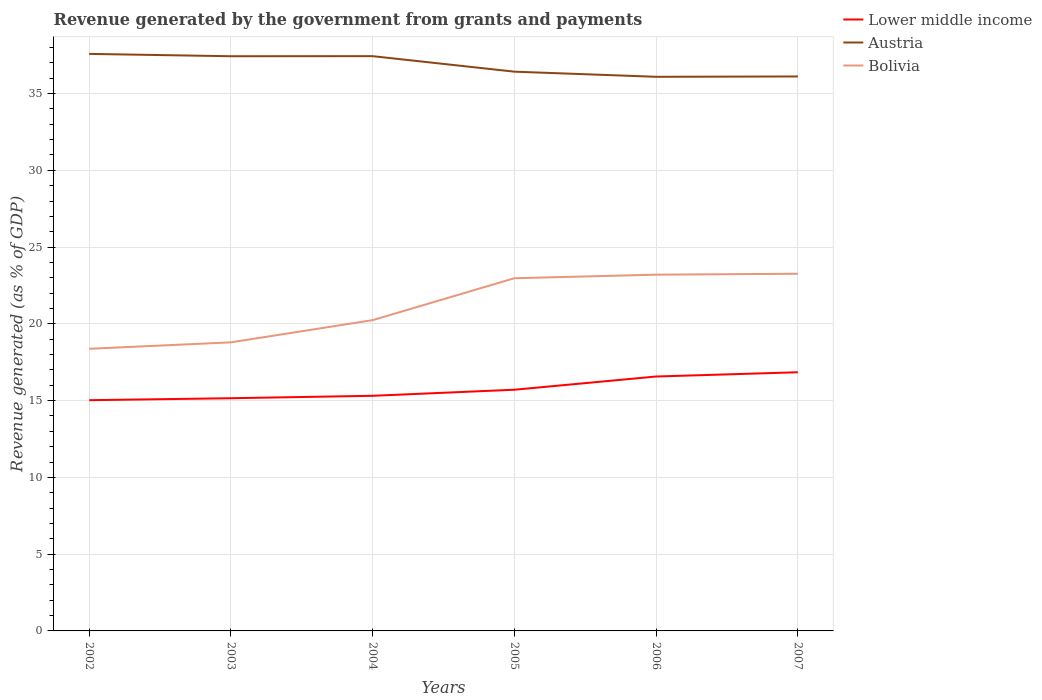Is the number of lines equal to the number of legend labels?
Make the answer very short. Yes. Across all years, what is the maximum revenue generated by the government in Lower middle income?
Offer a terse response. 15.03. What is the total revenue generated by the government in Austria in the graph?
Ensure brevity in your answer.  1.32. What is the difference between the highest and the second highest revenue generated by the government in Lower middle income?
Offer a terse response. 1.82. How many years are there in the graph?
Keep it short and to the point. 6. What is the difference between two consecutive major ticks on the Y-axis?
Provide a short and direct response. 5. Are the values on the major ticks of Y-axis written in scientific E-notation?
Ensure brevity in your answer.  No. Does the graph contain any zero values?
Make the answer very short. No. Where does the legend appear in the graph?
Your answer should be compact. Top right. How are the legend labels stacked?
Provide a succinct answer. Vertical. What is the title of the graph?
Offer a terse response. Revenue generated by the government from grants and payments. Does "Costa Rica" appear as one of the legend labels in the graph?
Offer a terse response. No. What is the label or title of the X-axis?
Your answer should be very brief. Years. What is the label or title of the Y-axis?
Keep it short and to the point. Revenue generated (as % of GDP). What is the Revenue generated (as % of GDP) of Lower middle income in 2002?
Provide a short and direct response. 15.03. What is the Revenue generated (as % of GDP) of Austria in 2002?
Offer a terse response. 37.58. What is the Revenue generated (as % of GDP) in Bolivia in 2002?
Give a very brief answer. 18.38. What is the Revenue generated (as % of GDP) of Lower middle income in 2003?
Provide a succinct answer. 15.16. What is the Revenue generated (as % of GDP) in Austria in 2003?
Give a very brief answer. 37.43. What is the Revenue generated (as % of GDP) of Bolivia in 2003?
Make the answer very short. 18.8. What is the Revenue generated (as % of GDP) in Lower middle income in 2004?
Provide a short and direct response. 15.31. What is the Revenue generated (as % of GDP) of Austria in 2004?
Your answer should be compact. 37.44. What is the Revenue generated (as % of GDP) in Bolivia in 2004?
Make the answer very short. 20.24. What is the Revenue generated (as % of GDP) of Lower middle income in 2005?
Your answer should be compact. 15.71. What is the Revenue generated (as % of GDP) of Austria in 2005?
Your answer should be very brief. 36.43. What is the Revenue generated (as % of GDP) of Bolivia in 2005?
Offer a very short reply. 22.97. What is the Revenue generated (as % of GDP) of Lower middle income in 2006?
Offer a very short reply. 16.57. What is the Revenue generated (as % of GDP) of Austria in 2006?
Your answer should be very brief. 36.09. What is the Revenue generated (as % of GDP) in Bolivia in 2006?
Provide a short and direct response. 23.2. What is the Revenue generated (as % of GDP) in Lower middle income in 2007?
Provide a short and direct response. 16.85. What is the Revenue generated (as % of GDP) of Austria in 2007?
Provide a succinct answer. 36.11. What is the Revenue generated (as % of GDP) in Bolivia in 2007?
Keep it short and to the point. 23.27. Across all years, what is the maximum Revenue generated (as % of GDP) of Lower middle income?
Ensure brevity in your answer.  16.85. Across all years, what is the maximum Revenue generated (as % of GDP) in Austria?
Your answer should be very brief. 37.58. Across all years, what is the maximum Revenue generated (as % of GDP) in Bolivia?
Ensure brevity in your answer.  23.27. Across all years, what is the minimum Revenue generated (as % of GDP) of Lower middle income?
Your response must be concise. 15.03. Across all years, what is the minimum Revenue generated (as % of GDP) in Austria?
Give a very brief answer. 36.09. Across all years, what is the minimum Revenue generated (as % of GDP) of Bolivia?
Offer a very short reply. 18.38. What is the total Revenue generated (as % of GDP) of Lower middle income in the graph?
Provide a succinct answer. 94.63. What is the total Revenue generated (as % of GDP) of Austria in the graph?
Make the answer very short. 221.09. What is the total Revenue generated (as % of GDP) of Bolivia in the graph?
Provide a succinct answer. 126.86. What is the difference between the Revenue generated (as % of GDP) of Lower middle income in 2002 and that in 2003?
Make the answer very short. -0.13. What is the difference between the Revenue generated (as % of GDP) of Austria in 2002 and that in 2003?
Keep it short and to the point. 0.15. What is the difference between the Revenue generated (as % of GDP) in Bolivia in 2002 and that in 2003?
Provide a short and direct response. -0.42. What is the difference between the Revenue generated (as % of GDP) in Lower middle income in 2002 and that in 2004?
Make the answer very short. -0.29. What is the difference between the Revenue generated (as % of GDP) in Austria in 2002 and that in 2004?
Make the answer very short. 0.15. What is the difference between the Revenue generated (as % of GDP) in Bolivia in 2002 and that in 2004?
Offer a terse response. -1.87. What is the difference between the Revenue generated (as % of GDP) in Lower middle income in 2002 and that in 2005?
Offer a terse response. -0.68. What is the difference between the Revenue generated (as % of GDP) in Austria in 2002 and that in 2005?
Your answer should be very brief. 1.16. What is the difference between the Revenue generated (as % of GDP) in Bolivia in 2002 and that in 2005?
Offer a very short reply. -4.6. What is the difference between the Revenue generated (as % of GDP) of Lower middle income in 2002 and that in 2006?
Your answer should be compact. -1.54. What is the difference between the Revenue generated (as % of GDP) of Austria in 2002 and that in 2006?
Provide a short and direct response. 1.49. What is the difference between the Revenue generated (as % of GDP) in Bolivia in 2002 and that in 2006?
Keep it short and to the point. -4.83. What is the difference between the Revenue generated (as % of GDP) in Lower middle income in 2002 and that in 2007?
Keep it short and to the point. -1.82. What is the difference between the Revenue generated (as % of GDP) in Austria in 2002 and that in 2007?
Your answer should be compact. 1.47. What is the difference between the Revenue generated (as % of GDP) of Bolivia in 2002 and that in 2007?
Make the answer very short. -4.89. What is the difference between the Revenue generated (as % of GDP) in Lower middle income in 2003 and that in 2004?
Provide a short and direct response. -0.16. What is the difference between the Revenue generated (as % of GDP) of Austria in 2003 and that in 2004?
Offer a very short reply. -0. What is the difference between the Revenue generated (as % of GDP) of Bolivia in 2003 and that in 2004?
Your answer should be compact. -1.45. What is the difference between the Revenue generated (as % of GDP) of Lower middle income in 2003 and that in 2005?
Offer a very short reply. -0.55. What is the difference between the Revenue generated (as % of GDP) in Austria in 2003 and that in 2005?
Keep it short and to the point. 1.01. What is the difference between the Revenue generated (as % of GDP) of Bolivia in 2003 and that in 2005?
Keep it short and to the point. -4.18. What is the difference between the Revenue generated (as % of GDP) of Lower middle income in 2003 and that in 2006?
Give a very brief answer. -1.41. What is the difference between the Revenue generated (as % of GDP) of Austria in 2003 and that in 2006?
Make the answer very short. 1.34. What is the difference between the Revenue generated (as % of GDP) of Bolivia in 2003 and that in 2006?
Ensure brevity in your answer.  -4.41. What is the difference between the Revenue generated (as % of GDP) of Lower middle income in 2003 and that in 2007?
Your answer should be very brief. -1.69. What is the difference between the Revenue generated (as % of GDP) of Austria in 2003 and that in 2007?
Offer a terse response. 1.32. What is the difference between the Revenue generated (as % of GDP) of Bolivia in 2003 and that in 2007?
Offer a very short reply. -4.47. What is the difference between the Revenue generated (as % of GDP) in Lower middle income in 2004 and that in 2005?
Your answer should be very brief. -0.4. What is the difference between the Revenue generated (as % of GDP) of Austria in 2004 and that in 2005?
Your response must be concise. 1.01. What is the difference between the Revenue generated (as % of GDP) of Bolivia in 2004 and that in 2005?
Your answer should be compact. -2.73. What is the difference between the Revenue generated (as % of GDP) of Lower middle income in 2004 and that in 2006?
Provide a succinct answer. -1.26. What is the difference between the Revenue generated (as % of GDP) in Austria in 2004 and that in 2006?
Provide a succinct answer. 1.34. What is the difference between the Revenue generated (as % of GDP) of Bolivia in 2004 and that in 2006?
Ensure brevity in your answer.  -2.96. What is the difference between the Revenue generated (as % of GDP) in Lower middle income in 2004 and that in 2007?
Give a very brief answer. -1.53. What is the difference between the Revenue generated (as % of GDP) in Austria in 2004 and that in 2007?
Make the answer very short. 1.32. What is the difference between the Revenue generated (as % of GDP) in Bolivia in 2004 and that in 2007?
Make the answer very short. -3.02. What is the difference between the Revenue generated (as % of GDP) in Lower middle income in 2005 and that in 2006?
Make the answer very short. -0.86. What is the difference between the Revenue generated (as % of GDP) in Austria in 2005 and that in 2006?
Provide a short and direct response. 0.33. What is the difference between the Revenue generated (as % of GDP) of Bolivia in 2005 and that in 2006?
Provide a short and direct response. -0.23. What is the difference between the Revenue generated (as % of GDP) in Lower middle income in 2005 and that in 2007?
Your response must be concise. -1.14. What is the difference between the Revenue generated (as % of GDP) in Austria in 2005 and that in 2007?
Your response must be concise. 0.31. What is the difference between the Revenue generated (as % of GDP) in Bolivia in 2005 and that in 2007?
Your answer should be compact. -0.29. What is the difference between the Revenue generated (as % of GDP) of Lower middle income in 2006 and that in 2007?
Offer a very short reply. -0.28. What is the difference between the Revenue generated (as % of GDP) in Austria in 2006 and that in 2007?
Keep it short and to the point. -0.02. What is the difference between the Revenue generated (as % of GDP) of Bolivia in 2006 and that in 2007?
Keep it short and to the point. -0.06. What is the difference between the Revenue generated (as % of GDP) of Lower middle income in 2002 and the Revenue generated (as % of GDP) of Austria in 2003?
Your answer should be very brief. -22.4. What is the difference between the Revenue generated (as % of GDP) in Lower middle income in 2002 and the Revenue generated (as % of GDP) in Bolivia in 2003?
Offer a very short reply. -3.77. What is the difference between the Revenue generated (as % of GDP) of Austria in 2002 and the Revenue generated (as % of GDP) of Bolivia in 2003?
Ensure brevity in your answer.  18.79. What is the difference between the Revenue generated (as % of GDP) in Lower middle income in 2002 and the Revenue generated (as % of GDP) in Austria in 2004?
Offer a very short reply. -22.41. What is the difference between the Revenue generated (as % of GDP) in Lower middle income in 2002 and the Revenue generated (as % of GDP) in Bolivia in 2004?
Provide a succinct answer. -5.21. What is the difference between the Revenue generated (as % of GDP) of Austria in 2002 and the Revenue generated (as % of GDP) of Bolivia in 2004?
Your response must be concise. 17.34. What is the difference between the Revenue generated (as % of GDP) of Lower middle income in 2002 and the Revenue generated (as % of GDP) of Austria in 2005?
Your response must be concise. -21.4. What is the difference between the Revenue generated (as % of GDP) of Lower middle income in 2002 and the Revenue generated (as % of GDP) of Bolivia in 2005?
Provide a succinct answer. -7.94. What is the difference between the Revenue generated (as % of GDP) in Austria in 2002 and the Revenue generated (as % of GDP) in Bolivia in 2005?
Offer a very short reply. 14.61. What is the difference between the Revenue generated (as % of GDP) of Lower middle income in 2002 and the Revenue generated (as % of GDP) of Austria in 2006?
Offer a very short reply. -21.06. What is the difference between the Revenue generated (as % of GDP) of Lower middle income in 2002 and the Revenue generated (as % of GDP) of Bolivia in 2006?
Give a very brief answer. -8.18. What is the difference between the Revenue generated (as % of GDP) of Austria in 2002 and the Revenue generated (as % of GDP) of Bolivia in 2006?
Offer a terse response. 14.38. What is the difference between the Revenue generated (as % of GDP) of Lower middle income in 2002 and the Revenue generated (as % of GDP) of Austria in 2007?
Provide a succinct answer. -21.09. What is the difference between the Revenue generated (as % of GDP) in Lower middle income in 2002 and the Revenue generated (as % of GDP) in Bolivia in 2007?
Provide a short and direct response. -8.24. What is the difference between the Revenue generated (as % of GDP) in Austria in 2002 and the Revenue generated (as % of GDP) in Bolivia in 2007?
Make the answer very short. 14.32. What is the difference between the Revenue generated (as % of GDP) of Lower middle income in 2003 and the Revenue generated (as % of GDP) of Austria in 2004?
Your response must be concise. -22.28. What is the difference between the Revenue generated (as % of GDP) of Lower middle income in 2003 and the Revenue generated (as % of GDP) of Bolivia in 2004?
Make the answer very short. -5.09. What is the difference between the Revenue generated (as % of GDP) in Austria in 2003 and the Revenue generated (as % of GDP) in Bolivia in 2004?
Provide a short and direct response. 17.19. What is the difference between the Revenue generated (as % of GDP) in Lower middle income in 2003 and the Revenue generated (as % of GDP) in Austria in 2005?
Provide a succinct answer. -21.27. What is the difference between the Revenue generated (as % of GDP) in Lower middle income in 2003 and the Revenue generated (as % of GDP) in Bolivia in 2005?
Keep it short and to the point. -7.82. What is the difference between the Revenue generated (as % of GDP) of Austria in 2003 and the Revenue generated (as % of GDP) of Bolivia in 2005?
Give a very brief answer. 14.46. What is the difference between the Revenue generated (as % of GDP) of Lower middle income in 2003 and the Revenue generated (as % of GDP) of Austria in 2006?
Your answer should be very brief. -20.94. What is the difference between the Revenue generated (as % of GDP) in Lower middle income in 2003 and the Revenue generated (as % of GDP) in Bolivia in 2006?
Provide a succinct answer. -8.05. What is the difference between the Revenue generated (as % of GDP) in Austria in 2003 and the Revenue generated (as % of GDP) in Bolivia in 2006?
Your answer should be compact. 14.23. What is the difference between the Revenue generated (as % of GDP) of Lower middle income in 2003 and the Revenue generated (as % of GDP) of Austria in 2007?
Your answer should be compact. -20.96. What is the difference between the Revenue generated (as % of GDP) of Lower middle income in 2003 and the Revenue generated (as % of GDP) of Bolivia in 2007?
Provide a succinct answer. -8.11. What is the difference between the Revenue generated (as % of GDP) of Austria in 2003 and the Revenue generated (as % of GDP) of Bolivia in 2007?
Ensure brevity in your answer.  14.17. What is the difference between the Revenue generated (as % of GDP) in Lower middle income in 2004 and the Revenue generated (as % of GDP) in Austria in 2005?
Provide a succinct answer. -21.11. What is the difference between the Revenue generated (as % of GDP) of Lower middle income in 2004 and the Revenue generated (as % of GDP) of Bolivia in 2005?
Your answer should be very brief. -7.66. What is the difference between the Revenue generated (as % of GDP) of Austria in 2004 and the Revenue generated (as % of GDP) of Bolivia in 2005?
Your answer should be compact. 14.46. What is the difference between the Revenue generated (as % of GDP) of Lower middle income in 2004 and the Revenue generated (as % of GDP) of Austria in 2006?
Make the answer very short. -20.78. What is the difference between the Revenue generated (as % of GDP) of Lower middle income in 2004 and the Revenue generated (as % of GDP) of Bolivia in 2006?
Ensure brevity in your answer.  -7.89. What is the difference between the Revenue generated (as % of GDP) of Austria in 2004 and the Revenue generated (as % of GDP) of Bolivia in 2006?
Give a very brief answer. 14.23. What is the difference between the Revenue generated (as % of GDP) of Lower middle income in 2004 and the Revenue generated (as % of GDP) of Austria in 2007?
Ensure brevity in your answer.  -20.8. What is the difference between the Revenue generated (as % of GDP) of Lower middle income in 2004 and the Revenue generated (as % of GDP) of Bolivia in 2007?
Give a very brief answer. -7.95. What is the difference between the Revenue generated (as % of GDP) of Austria in 2004 and the Revenue generated (as % of GDP) of Bolivia in 2007?
Give a very brief answer. 14.17. What is the difference between the Revenue generated (as % of GDP) in Lower middle income in 2005 and the Revenue generated (as % of GDP) in Austria in 2006?
Your answer should be very brief. -20.38. What is the difference between the Revenue generated (as % of GDP) in Lower middle income in 2005 and the Revenue generated (as % of GDP) in Bolivia in 2006?
Provide a short and direct response. -7.49. What is the difference between the Revenue generated (as % of GDP) of Austria in 2005 and the Revenue generated (as % of GDP) of Bolivia in 2006?
Provide a short and direct response. 13.22. What is the difference between the Revenue generated (as % of GDP) in Lower middle income in 2005 and the Revenue generated (as % of GDP) in Austria in 2007?
Provide a succinct answer. -20.41. What is the difference between the Revenue generated (as % of GDP) in Lower middle income in 2005 and the Revenue generated (as % of GDP) in Bolivia in 2007?
Offer a very short reply. -7.56. What is the difference between the Revenue generated (as % of GDP) of Austria in 2005 and the Revenue generated (as % of GDP) of Bolivia in 2007?
Give a very brief answer. 13.16. What is the difference between the Revenue generated (as % of GDP) in Lower middle income in 2006 and the Revenue generated (as % of GDP) in Austria in 2007?
Your response must be concise. -19.54. What is the difference between the Revenue generated (as % of GDP) of Lower middle income in 2006 and the Revenue generated (as % of GDP) of Bolivia in 2007?
Keep it short and to the point. -6.69. What is the difference between the Revenue generated (as % of GDP) in Austria in 2006 and the Revenue generated (as % of GDP) in Bolivia in 2007?
Make the answer very short. 12.83. What is the average Revenue generated (as % of GDP) in Lower middle income per year?
Provide a short and direct response. 15.77. What is the average Revenue generated (as % of GDP) in Austria per year?
Provide a short and direct response. 36.85. What is the average Revenue generated (as % of GDP) of Bolivia per year?
Ensure brevity in your answer.  21.14. In the year 2002, what is the difference between the Revenue generated (as % of GDP) of Lower middle income and Revenue generated (as % of GDP) of Austria?
Provide a succinct answer. -22.56. In the year 2002, what is the difference between the Revenue generated (as % of GDP) in Lower middle income and Revenue generated (as % of GDP) in Bolivia?
Offer a terse response. -3.35. In the year 2002, what is the difference between the Revenue generated (as % of GDP) of Austria and Revenue generated (as % of GDP) of Bolivia?
Your answer should be compact. 19.21. In the year 2003, what is the difference between the Revenue generated (as % of GDP) in Lower middle income and Revenue generated (as % of GDP) in Austria?
Ensure brevity in your answer.  -22.28. In the year 2003, what is the difference between the Revenue generated (as % of GDP) of Lower middle income and Revenue generated (as % of GDP) of Bolivia?
Your answer should be very brief. -3.64. In the year 2003, what is the difference between the Revenue generated (as % of GDP) of Austria and Revenue generated (as % of GDP) of Bolivia?
Provide a short and direct response. 18.64. In the year 2004, what is the difference between the Revenue generated (as % of GDP) in Lower middle income and Revenue generated (as % of GDP) in Austria?
Your answer should be very brief. -22.12. In the year 2004, what is the difference between the Revenue generated (as % of GDP) of Lower middle income and Revenue generated (as % of GDP) of Bolivia?
Offer a terse response. -4.93. In the year 2004, what is the difference between the Revenue generated (as % of GDP) of Austria and Revenue generated (as % of GDP) of Bolivia?
Your response must be concise. 17.19. In the year 2005, what is the difference between the Revenue generated (as % of GDP) of Lower middle income and Revenue generated (as % of GDP) of Austria?
Your answer should be very brief. -20.72. In the year 2005, what is the difference between the Revenue generated (as % of GDP) in Lower middle income and Revenue generated (as % of GDP) in Bolivia?
Provide a short and direct response. -7.26. In the year 2005, what is the difference between the Revenue generated (as % of GDP) in Austria and Revenue generated (as % of GDP) in Bolivia?
Ensure brevity in your answer.  13.45. In the year 2006, what is the difference between the Revenue generated (as % of GDP) of Lower middle income and Revenue generated (as % of GDP) of Austria?
Your response must be concise. -19.52. In the year 2006, what is the difference between the Revenue generated (as % of GDP) in Lower middle income and Revenue generated (as % of GDP) in Bolivia?
Offer a very short reply. -6.63. In the year 2006, what is the difference between the Revenue generated (as % of GDP) of Austria and Revenue generated (as % of GDP) of Bolivia?
Your answer should be compact. 12.89. In the year 2007, what is the difference between the Revenue generated (as % of GDP) in Lower middle income and Revenue generated (as % of GDP) in Austria?
Your answer should be compact. -19.27. In the year 2007, what is the difference between the Revenue generated (as % of GDP) of Lower middle income and Revenue generated (as % of GDP) of Bolivia?
Your answer should be very brief. -6.42. In the year 2007, what is the difference between the Revenue generated (as % of GDP) of Austria and Revenue generated (as % of GDP) of Bolivia?
Offer a terse response. 12.85. What is the ratio of the Revenue generated (as % of GDP) in Lower middle income in 2002 to that in 2003?
Make the answer very short. 0.99. What is the ratio of the Revenue generated (as % of GDP) of Austria in 2002 to that in 2003?
Make the answer very short. 1. What is the ratio of the Revenue generated (as % of GDP) of Bolivia in 2002 to that in 2003?
Offer a very short reply. 0.98. What is the ratio of the Revenue generated (as % of GDP) of Lower middle income in 2002 to that in 2004?
Provide a short and direct response. 0.98. What is the ratio of the Revenue generated (as % of GDP) of Bolivia in 2002 to that in 2004?
Provide a succinct answer. 0.91. What is the ratio of the Revenue generated (as % of GDP) of Lower middle income in 2002 to that in 2005?
Offer a very short reply. 0.96. What is the ratio of the Revenue generated (as % of GDP) in Austria in 2002 to that in 2005?
Keep it short and to the point. 1.03. What is the ratio of the Revenue generated (as % of GDP) in Lower middle income in 2002 to that in 2006?
Offer a terse response. 0.91. What is the ratio of the Revenue generated (as % of GDP) of Austria in 2002 to that in 2006?
Ensure brevity in your answer.  1.04. What is the ratio of the Revenue generated (as % of GDP) in Bolivia in 2002 to that in 2006?
Provide a succinct answer. 0.79. What is the ratio of the Revenue generated (as % of GDP) in Lower middle income in 2002 to that in 2007?
Provide a succinct answer. 0.89. What is the ratio of the Revenue generated (as % of GDP) of Austria in 2002 to that in 2007?
Your answer should be compact. 1.04. What is the ratio of the Revenue generated (as % of GDP) of Bolivia in 2002 to that in 2007?
Your answer should be compact. 0.79. What is the ratio of the Revenue generated (as % of GDP) in Lower middle income in 2003 to that in 2004?
Make the answer very short. 0.99. What is the ratio of the Revenue generated (as % of GDP) of Austria in 2003 to that in 2004?
Your answer should be very brief. 1. What is the ratio of the Revenue generated (as % of GDP) of Bolivia in 2003 to that in 2004?
Your response must be concise. 0.93. What is the ratio of the Revenue generated (as % of GDP) in Lower middle income in 2003 to that in 2005?
Make the answer very short. 0.96. What is the ratio of the Revenue generated (as % of GDP) of Austria in 2003 to that in 2005?
Make the answer very short. 1.03. What is the ratio of the Revenue generated (as % of GDP) in Bolivia in 2003 to that in 2005?
Your response must be concise. 0.82. What is the ratio of the Revenue generated (as % of GDP) in Lower middle income in 2003 to that in 2006?
Your answer should be compact. 0.91. What is the ratio of the Revenue generated (as % of GDP) in Austria in 2003 to that in 2006?
Ensure brevity in your answer.  1.04. What is the ratio of the Revenue generated (as % of GDP) of Bolivia in 2003 to that in 2006?
Your response must be concise. 0.81. What is the ratio of the Revenue generated (as % of GDP) of Lower middle income in 2003 to that in 2007?
Provide a short and direct response. 0.9. What is the ratio of the Revenue generated (as % of GDP) of Austria in 2003 to that in 2007?
Give a very brief answer. 1.04. What is the ratio of the Revenue generated (as % of GDP) in Bolivia in 2003 to that in 2007?
Make the answer very short. 0.81. What is the ratio of the Revenue generated (as % of GDP) of Lower middle income in 2004 to that in 2005?
Offer a terse response. 0.97. What is the ratio of the Revenue generated (as % of GDP) in Austria in 2004 to that in 2005?
Provide a short and direct response. 1.03. What is the ratio of the Revenue generated (as % of GDP) in Bolivia in 2004 to that in 2005?
Ensure brevity in your answer.  0.88. What is the ratio of the Revenue generated (as % of GDP) of Lower middle income in 2004 to that in 2006?
Offer a terse response. 0.92. What is the ratio of the Revenue generated (as % of GDP) in Austria in 2004 to that in 2006?
Keep it short and to the point. 1.04. What is the ratio of the Revenue generated (as % of GDP) of Bolivia in 2004 to that in 2006?
Provide a short and direct response. 0.87. What is the ratio of the Revenue generated (as % of GDP) of Lower middle income in 2004 to that in 2007?
Your answer should be very brief. 0.91. What is the ratio of the Revenue generated (as % of GDP) of Austria in 2004 to that in 2007?
Your answer should be very brief. 1.04. What is the ratio of the Revenue generated (as % of GDP) in Bolivia in 2004 to that in 2007?
Your response must be concise. 0.87. What is the ratio of the Revenue generated (as % of GDP) of Lower middle income in 2005 to that in 2006?
Your answer should be very brief. 0.95. What is the ratio of the Revenue generated (as % of GDP) of Austria in 2005 to that in 2006?
Give a very brief answer. 1.01. What is the ratio of the Revenue generated (as % of GDP) of Lower middle income in 2005 to that in 2007?
Your answer should be compact. 0.93. What is the ratio of the Revenue generated (as % of GDP) of Austria in 2005 to that in 2007?
Give a very brief answer. 1.01. What is the ratio of the Revenue generated (as % of GDP) of Bolivia in 2005 to that in 2007?
Provide a short and direct response. 0.99. What is the ratio of the Revenue generated (as % of GDP) in Lower middle income in 2006 to that in 2007?
Ensure brevity in your answer.  0.98. What is the ratio of the Revenue generated (as % of GDP) in Austria in 2006 to that in 2007?
Provide a short and direct response. 1. What is the ratio of the Revenue generated (as % of GDP) of Bolivia in 2006 to that in 2007?
Offer a very short reply. 1. What is the difference between the highest and the second highest Revenue generated (as % of GDP) in Lower middle income?
Keep it short and to the point. 0.28. What is the difference between the highest and the second highest Revenue generated (as % of GDP) of Austria?
Keep it short and to the point. 0.15. What is the difference between the highest and the second highest Revenue generated (as % of GDP) of Bolivia?
Make the answer very short. 0.06. What is the difference between the highest and the lowest Revenue generated (as % of GDP) in Lower middle income?
Keep it short and to the point. 1.82. What is the difference between the highest and the lowest Revenue generated (as % of GDP) in Austria?
Keep it short and to the point. 1.49. What is the difference between the highest and the lowest Revenue generated (as % of GDP) of Bolivia?
Offer a very short reply. 4.89. 